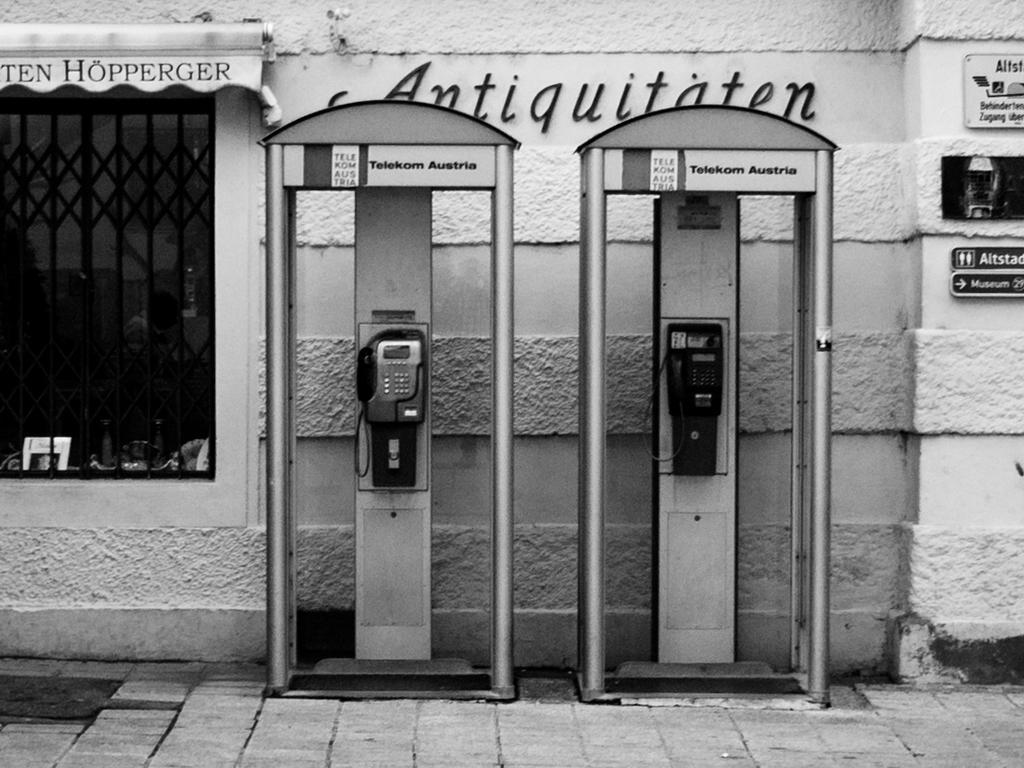Please provide a concise description of this image. This image consists of telephones. At the bottom, there is a road. On the left, we can see a window. In the background, there is a wall on which there is a name. On the right, we can see the boards. 